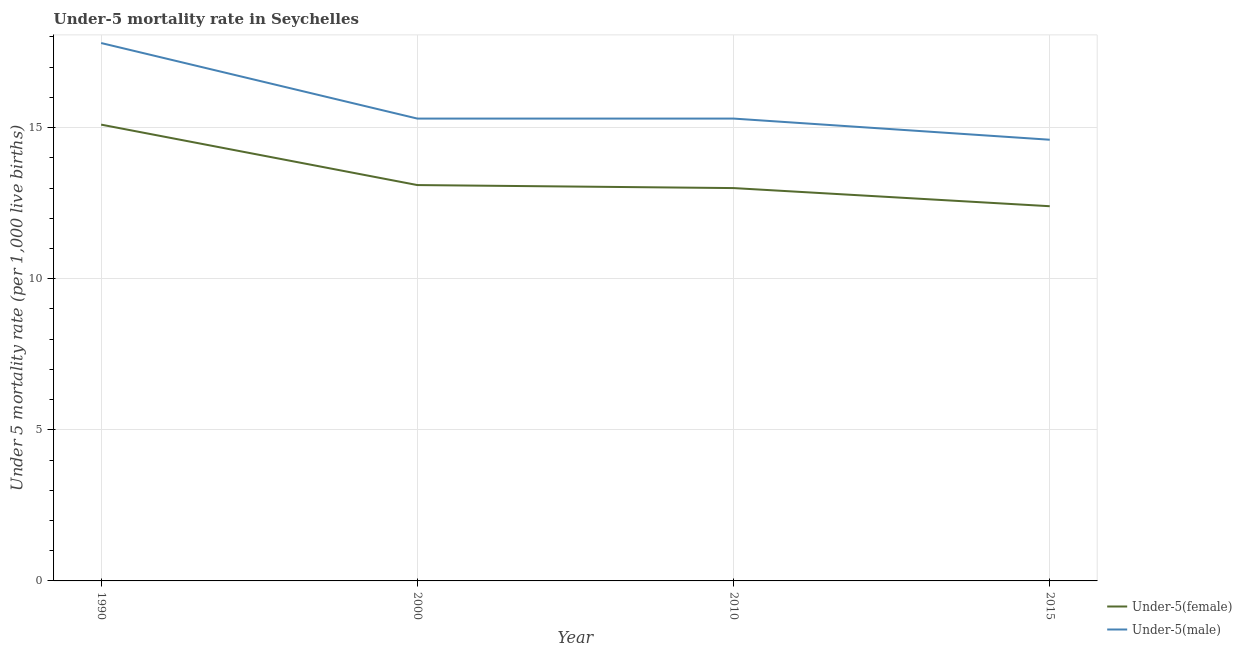How many different coloured lines are there?
Your answer should be very brief. 2. Does the line corresponding to under-5 male mortality rate intersect with the line corresponding to under-5 female mortality rate?
Make the answer very short. No. Is the number of lines equal to the number of legend labels?
Offer a very short reply. Yes. Across all years, what is the maximum under-5 female mortality rate?
Your response must be concise. 15.1. In which year was the under-5 male mortality rate maximum?
Your response must be concise. 1990. In which year was the under-5 female mortality rate minimum?
Provide a short and direct response. 2015. What is the total under-5 female mortality rate in the graph?
Make the answer very short. 53.6. What is the difference between the under-5 female mortality rate in 1990 and that in 2000?
Keep it short and to the point. 2. What is the difference between the under-5 female mortality rate in 2000 and the under-5 male mortality rate in 1990?
Provide a short and direct response. -4.7. What is the average under-5 male mortality rate per year?
Provide a short and direct response. 15.75. In the year 2010, what is the difference between the under-5 female mortality rate and under-5 male mortality rate?
Offer a very short reply. -2.3. In how many years, is the under-5 male mortality rate greater than 14?
Keep it short and to the point. 4. What is the ratio of the under-5 male mortality rate in 2000 to that in 2010?
Give a very brief answer. 1. Is the under-5 female mortality rate in 2000 less than that in 2010?
Give a very brief answer. No. What is the difference between the highest and the second highest under-5 male mortality rate?
Provide a succinct answer. 2.5. What is the difference between the highest and the lowest under-5 male mortality rate?
Keep it short and to the point. 3.2. In how many years, is the under-5 male mortality rate greater than the average under-5 male mortality rate taken over all years?
Offer a very short reply. 1. Does the under-5 female mortality rate monotonically increase over the years?
Your answer should be compact. No. Is the under-5 male mortality rate strictly greater than the under-5 female mortality rate over the years?
Provide a short and direct response. Yes. How many lines are there?
Provide a short and direct response. 2. How many years are there in the graph?
Provide a short and direct response. 4. Does the graph contain any zero values?
Provide a succinct answer. No. Does the graph contain grids?
Your response must be concise. Yes. How many legend labels are there?
Give a very brief answer. 2. How are the legend labels stacked?
Provide a succinct answer. Vertical. What is the title of the graph?
Your answer should be very brief. Under-5 mortality rate in Seychelles. Does "National Visitors" appear as one of the legend labels in the graph?
Ensure brevity in your answer.  No. What is the label or title of the Y-axis?
Make the answer very short. Under 5 mortality rate (per 1,0 live births). What is the Under 5 mortality rate (per 1,000 live births) of Under-5(female) in 1990?
Your answer should be compact. 15.1. What is the Under 5 mortality rate (per 1,000 live births) of Under-5(male) in 1990?
Ensure brevity in your answer.  17.8. What is the Under 5 mortality rate (per 1,000 live births) of Under-5(male) in 2000?
Your answer should be compact. 15.3. Across all years, what is the maximum Under 5 mortality rate (per 1,000 live births) of Under-5(female)?
Your response must be concise. 15.1. Across all years, what is the maximum Under 5 mortality rate (per 1,000 live births) of Under-5(male)?
Your answer should be very brief. 17.8. Across all years, what is the minimum Under 5 mortality rate (per 1,000 live births) of Under-5(female)?
Offer a terse response. 12.4. What is the total Under 5 mortality rate (per 1,000 live births) in Under-5(female) in the graph?
Provide a succinct answer. 53.6. What is the total Under 5 mortality rate (per 1,000 live births) of Under-5(male) in the graph?
Provide a short and direct response. 63. What is the difference between the Under 5 mortality rate (per 1,000 live births) in Under-5(female) in 1990 and that in 2000?
Give a very brief answer. 2. What is the difference between the Under 5 mortality rate (per 1,000 live births) of Under-5(male) in 1990 and that in 2000?
Provide a succinct answer. 2.5. What is the difference between the Under 5 mortality rate (per 1,000 live births) in Under-5(female) in 1990 and that in 2010?
Give a very brief answer. 2.1. What is the difference between the Under 5 mortality rate (per 1,000 live births) of Under-5(female) in 1990 and that in 2015?
Your answer should be compact. 2.7. What is the difference between the Under 5 mortality rate (per 1,000 live births) in Under-5(male) in 2000 and that in 2010?
Your answer should be very brief. 0. What is the difference between the Under 5 mortality rate (per 1,000 live births) in Under-5(female) in 2000 and that in 2015?
Make the answer very short. 0.7. What is the difference between the Under 5 mortality rate (per 1,000 live births) of Under-5(male) in 2000 and that in 2015?
Provide a succinct answer. 0.7. What is the difference between the Under 5 mortality rate (per 1,000 live births) of Under-5(male) in 2010 and that in 2015?
Ensure brevity in your answer.  0.7. What is the difference between the Under 5 mortality rate (per 1,000 live births) in Under-5(female) in 1990 and the Under 5 mortality rate (per 1,000 live births) in Under-5(male) in 2000?
Make the answer very short. -0.2. What is the difference between the Under 5 mortality rate (per 1,000 live births) of Under-5(female) in 1990 and the Under 5 mortality rate (per 1,000 live births) of Under-5(male) in 2015?
Provide a succinct answer. 0.5. What is the difference between the Under 5 mortality rate (per 1,000 live births) in Under-5(female) in 2000 and the Under 5 mortality rate (per 1,000 live births) in Under-5(male) in 2010?
Offer a very short reply. -2.2. What is the average Under 5 mortality rate (per 1,000 live births) in Under-5(male) per year?
Offer a terse response. 15.75. In the year 2000, what is the difference between the Under 5 mortality rate (per 1,000 live births) of Under-5(female) and Under 5 mortality rate (per 1,000 live births) of Under-5(male)?
Make the answer very short. -2.2. What is the ratio of the Under 5 mortality rate (per 1,000 live births) of Under-5(female) in 1990 to that in 2000?
Your answer should be compact. 1.15. What is the ratio of the Under 5 mortality rate (per 1,000 live births) of Under-5(male) in 1990 to that in 2000?
Offer a very short reply. 1.16. What is the ratio of the Under 5 mortality rate (per 1,000 live births) in Under-5(female) in 1990 to that in 2010?
Your answer should be compact. 1.16. What is the ratio of the Under 5 mortality rate (per 1,000 live births) in Under-5(male) in 1990 to that in 2010?
Provide a short and direct response. 1.16. What is the ratio of the Under 5 mortality rate (per 1,000 live births) of Under-5(female) in 1990 to that in 2015?
Provide a succinct answer. 1.22. What is the ratio of the Under 5 mortality rate (per 1,000 live births) in Under-5(male) in 1990 to that in 2015?
Provide a short and direct response. 1.22. What is the ratio of the Under 5 mortality rate (per 1,000 live births) of Under-5(female) in 2000 to that in 2010?
Keep it short and to the point. 1.01. What is the ratio of the Under 5 mortality rate (per 1,000 live births) in Under-5(male) in 2000 to that in 2010?
Your response must be concise. 1. What is the ratio of the Under 5 mortality rate (per 1,000 live births) of Under-5(female) in 2000 to that in 2015?
Ensure brevity in your answer.  1.06. What is the ratio of the Under 5 mortality rate (per 1,000 live births) in Under-5(male) in 2000 to that in 2015?
Give a very brief answer. 1.05. What is the ratio of the Under 5 mortality rate (per 1,000 live births) of Under-5(female) in 2010 to that in 2015?
Ensure brevity in your answer.  1.05. What is the ratio of the Under 5 mortality rate (per 1,000 live births) in Under-5(male) in 2010 to that in 2015?
Offer a terse response. 1.05. What is the difference between the highest and the second highest Under 5 mortality rate (per 1,000 live births) in Under-5(female)?
Ensure brevity in your answer.  2. 